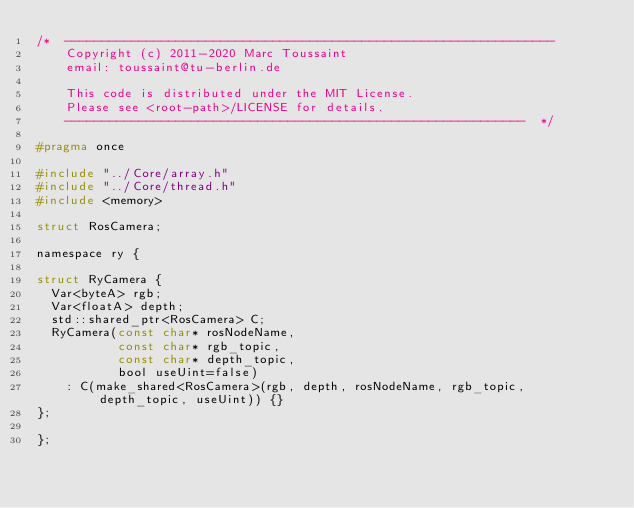Convert code to text. <code><loc_0><loc_0><loc_500><loc_500><_C_>/*  ------------------------------------------------------------------
    Copyright (c) 2011-2020 Marc Toussaint
    email: toussaint@tu-berlin.de

    This code is distributed under the MIT License.
    Please see <root-path>/LICENSE for details.
    --------------------------------------------------------------  */

#pragma once

#include "../Core/array.h"
#include "../Core/thread.h"
#include <memory>

struct RosCamera;

namespace ry {

struct RyCamera {
  Var<byteA> rgb;
  Var<floatA> depth;
  std::shared_ptr<RosCamera> C;
  RyCamera(const char* rosNodeName,
           const char* rgb_topic,
           const char* depth_topic,
           bool useUint=false)
    : C(make_shared<RosCamera>(rgb, depth, rosNodeName, rgb_topic, depth_topic, useUint)) {}
};

};

</code> 